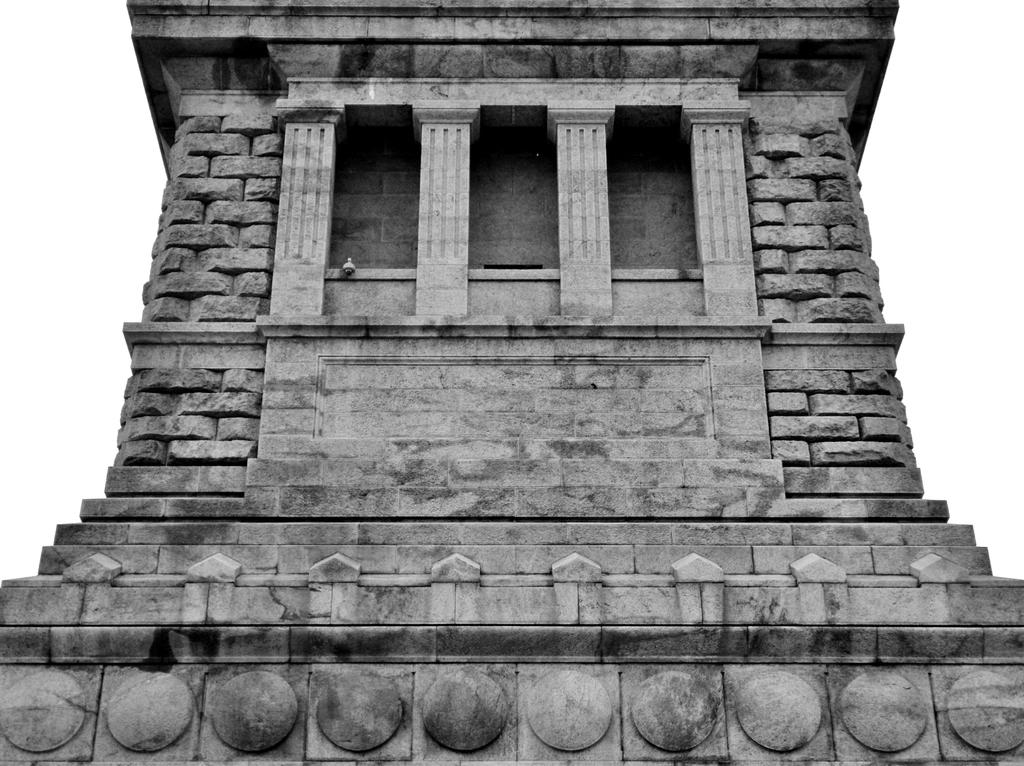What is the color scheme of the image? The image is black and white. What structure can be seen in the image? There is a building in the image. What material is used for the building's wall? The building has a stone wall. What is visible in the background of the image? The sky is visible in the background of the image. Is there a cup of coffee being read by someone in the image? There is no cup of coffee or person reading in the image, as it is a black and white image of a building with a stone wall and a visible sky in the background. 